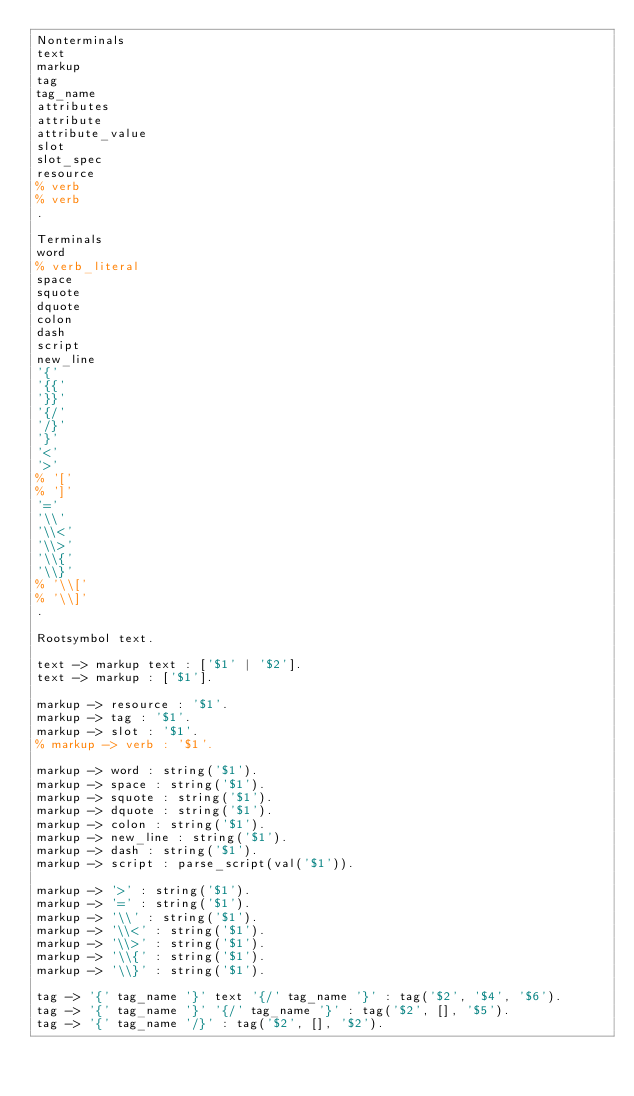<code> <loc_0><loc_0><loc_500><loc_500><_Erlang_>Nonterminals
text
markup
tag
tag_name
attributes
attribute
attribute_value
slot
slot_spec
resource
% verb
% verb
.

Terminals
word
% verb_literal
space
squote
dquote
colon
dash
script
new_line
'{'
'{{'
'}}'
'{/'
'/}'
'}'
'<'
'>'
% '['
% ']'
'='
'\\'
'\\<'
'\\>'
'\\{'
'\\}'
% '\\['
% '\\]'
.

Rootsymbol text.

text -> markup text : ['$1' | '$2'].
text -> markup : ['$1'].

markup -> resource : '$1'.
markup -> tag : '$1'.
markup -> slot : '$1'.
% markup -> verb : '$1'.

markup -> word : string('$1').
markup -> space : string('$1').
markup -> squote : string('$1').
markup -> dquote : string('$1').
markup -> colon : string('$1').
markup -> new_line : string('$1').
markup -> dash : string('$1').
markup -> script : parse_script(val('$1')).

markup -> '>' : string('$1').
markup -> '=' : string('$1').
markup -> '\\' : string('$1').
markup -> '\\<' : string('$1').
markup -> '\\>' : string('$1').
markup -> '\\{' : string('$1').
markup -> '\\}' : string('$1').

tag -> '{' tag_name '}' text '{/' tag_name '}' : tag('$2', '$4', '$6').
tag -> '{' tag_name '}' '{/' tag_name '}' : tag('$2', [], '$5').
tag -> '{' tag_name '/}' : tag('$2', [], '$2').</code> 